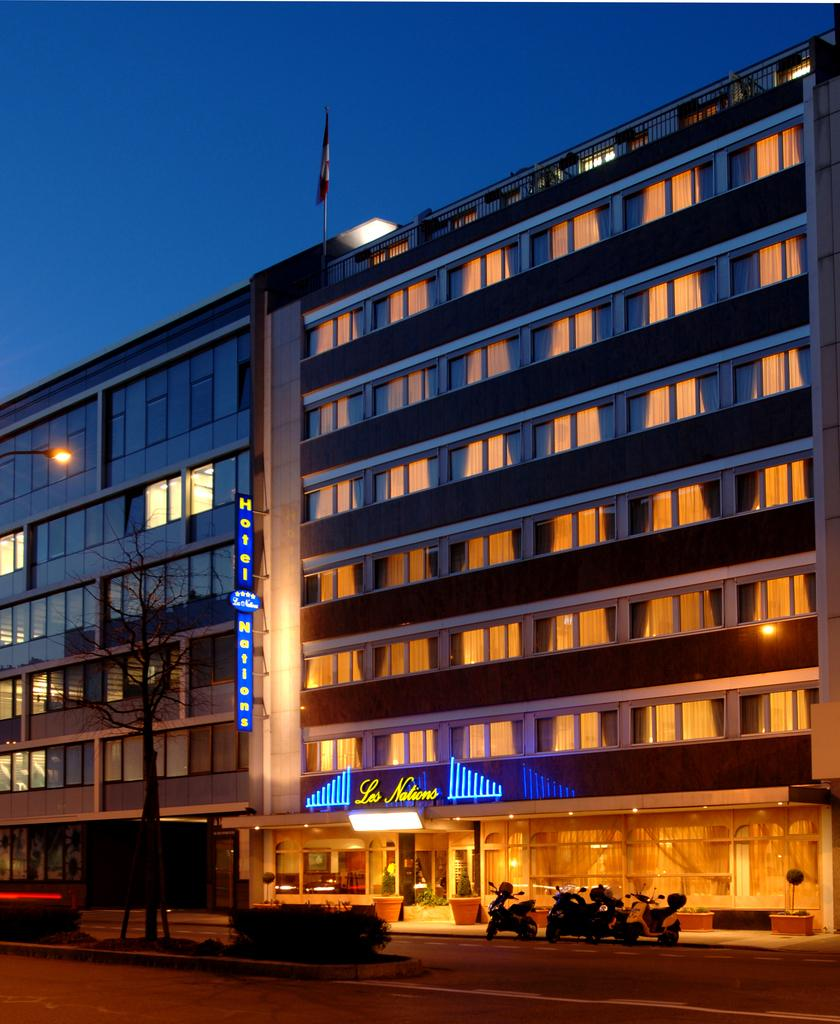What type of structures can be seen in the image? There are buildings in the image. What feature is common to some of the buildings? There are windows in the image. What type of lighting is present in the image? There is a streetlamp in the image. What type of vehicles are visible in the image? There are motorcycles in the image. What objects are present near the buildings? There are pots in the image. What type of living organisms are present in the image? There are plants in the image. What part of the natural environment is visible in the image? The sky is visible in the image. What type of soda is being served in the image? There is no soda present in the image. Can you tell me how many clocks are visible in the image? There are no clocks visible in the image. 